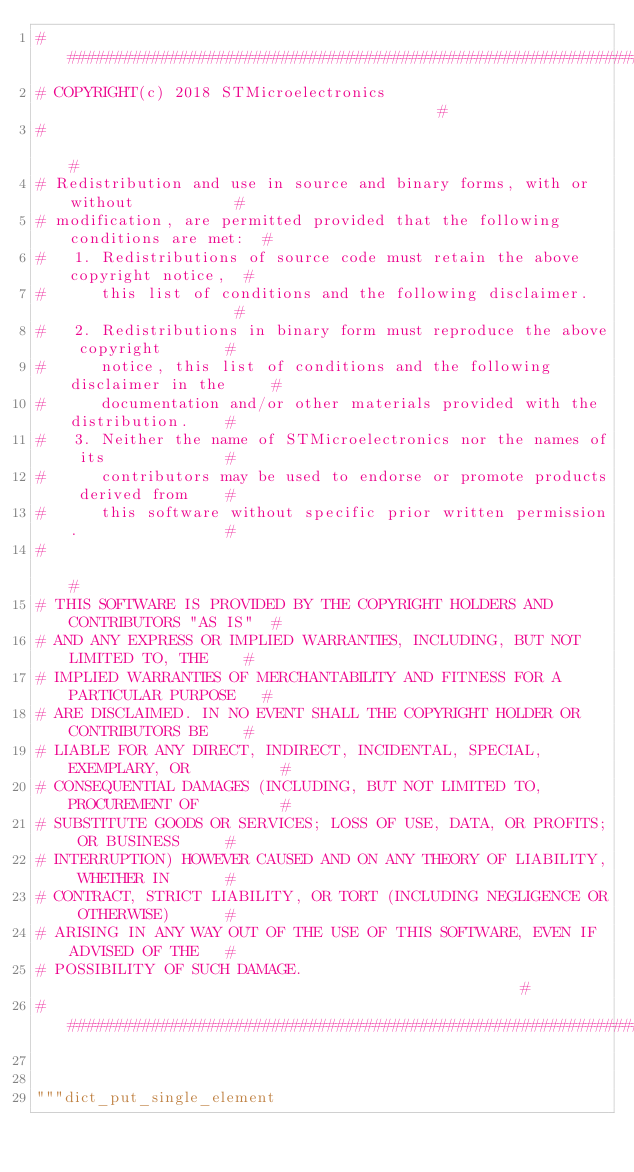Convert code to text. <code><loc_0><loc_0><loc_500><loc_500><_Python_>################################################################################
# COPYRIGHT(c) 2018 STMicroelectronics                                         #
#                                                                              #
# Redistribution and use in source and binary forms, with or without           #
# modification, are permitted provided that the following conditions are met:  #
#   1. Redistributions of source code must retain the above copyright notice,  #
#      this list of conditions and the following disclaimer.                   #
#   2. Redistributions in binary form must reproduce the above copyright       #
#      notice, this list of conditions and the following disclaimer in the     #
#      documentation and/or other materials provided with the distribution.    #
#   3. Neither the name of STMicroelectronics nor the names of its             #
#      contributors may be used to endorse or promote products derived from    #
#      this software without specific prior written permission.                #
#                                                                              #
# THIS SOFTWARE IS PROVIDED BY THE COPYRIGHT HOLDERS AND CONTRIBUTORS "AS IS"  #
# AND ANY EXPRESS OR IMPLIED WARRANTIES, INCLUDING, BUT NOT LIMITED TO, THE    #
# IMPLIED WARRANTIES OF MERCHANTABILITY AND FITNESS FOR A PARTICULAR PURPOSE   #
# ARE DISCLAIMED. IN NO EVENT SHALL THE COPYRIGHT HOLDER OR CONTRIBUTORS BE    #
# LIABLE FOR ANY DIRECT, INDIRECT, INCIDENTAL, SPECIAL, EXEMPLARY, OR          #
# CONSEQUENTIAL DAMAGES (INCLUDING, BUT NOT LIMITED TO, PROCUREMENT OF         #
# SUBSTITUTE GOODS OR SERVICES; LOSS OF USE, DATA, OR PROFITS; OR BUSINESS     #
# INTERRUPTION) HOWEVER CAUSED AND ON ANY THEORY OF LIABILITY, WHETHER IN      #
# CONTRACT, STRICT LIABILITY, OR TORT (INCLUDING NEGLIGENCE OR OTHERWISE)      #
# ARISING IN ANY WAY OUT OF THE USE OF THIS SOFTWARE, EVEN IF ADVISED OF THE   #
# POSSIBILITY OF SUCH DAMAGE.                                                  #
################################################################################


"""dict_put_single_element
</code> 